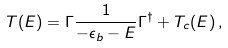<formula> <loc_0><loc_0><loc_500><loc_500>T ( E ) = \Gamma \frac { 1 } { - \epsilon _ { b } - E } \Gamma ^ { \dagger } + T _ { c } ( E ) \, ,</formula> 